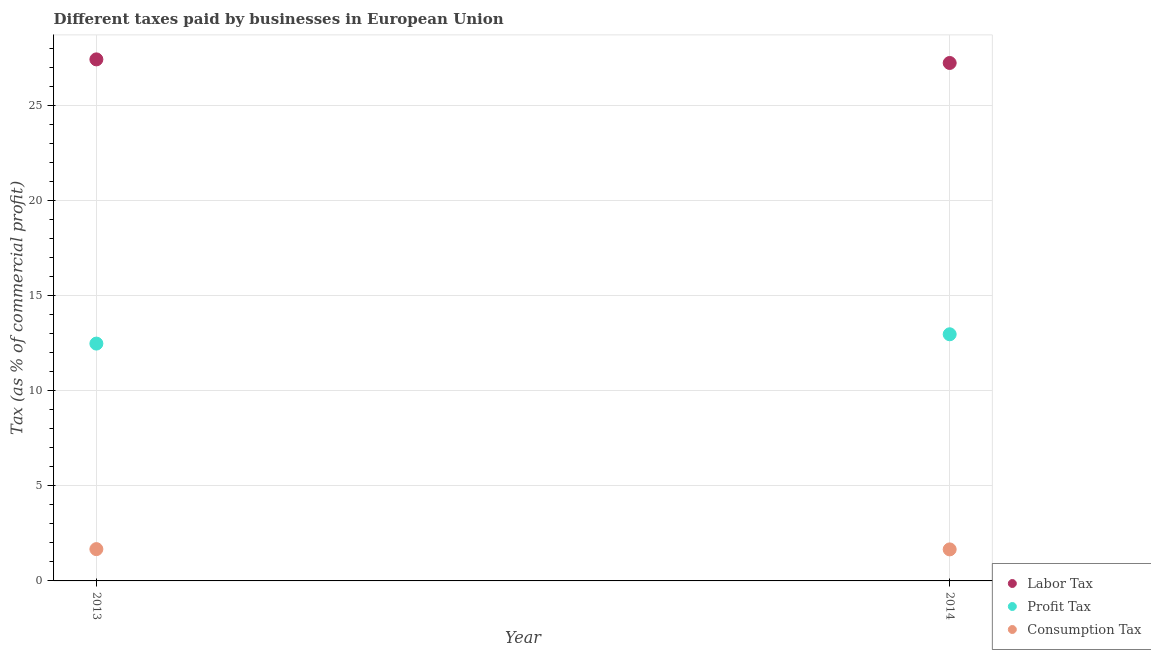How many different coloured dotlines are there?
Give a very brief answer. 3. Is the number of dotlines equal to the number of legend labels?
Provide a succinct answer. Yes. What is the percentage of labor tax in 2014?
Make the answer very short. 27.23. Across all years, what is the maximum percentage of profit tax?
Ensure brevity in your answer.  12.96. Across all years, what is the minimum percentage of profit tax?
Ensure brevity in your answer.  12.47. In which year was the percentage of consumption tax maximum?
Your response must be concise. 2013. What is the total percentage of consumption tax in the graph?
Provide a short and direct response. 3.33. What is the difference between the percentage of labor tax in 2013 and that in 2014?
Offer a terse response. 0.19. What is the difference between the percentage of profit tax in 2014 and the percentage of labor tax in 2013?
Provide a short and direct response. -14.45. What is the average percentage of consumption tax per year?
Your answer should be compact. 1.66. In the year 2014, what is the difference between the percentage of labor tax and percentage of consumption tax?
Offer a terse response. 25.57. In how many years, is the percentage of labor tax greater than 20 %?
Your answer should be compact. 2. What is the ratio of the percentage of profit tax in 2013 to that in 2014?
Keep it short and to the point. 0.96. Is the percentage of profit tax in 2013 less than that in 2014?
Ensure brevity in your answer.  Yes. How many years are there in the graph?
Your answer should be compact. 2. Does the graph contain any zero values?
Give a very brief answer. No. Does the graph contain grids?
Make the answer very short. Yes. Where does the legend appear in the graph?
Keep it short and to the point. Bottom right. How are the legend labels stacked?
Keep it short and to the point. Vertical. What is the title of the graph?
Keep it short and to the point. Different taxes paid by businesses in European Union. What is the label or title of the Y-axis?
Your answer should be compact. Tax (as % of commercial profit). What is the Tax (as % of commercial profit) in Labor Tax in 2013?
Ensure brevity in your answer.  27.41. What is the Tax (as % of commercial profit) in Profit Tax in 2013?
Provide a short and direct response. 12.47. What is the Tax (as % of commercial profit) of Consumption Tax in 2013?
Provide a succinct answer. 1.67. What is the Tax (as % of commercial profit) in Labor Tax in 2014?
Keep it short and to the point. 27.23. What is the Tax (as % of commercial profit) in Profit Tax in 2014?
Your response must be concise. 12.96. What is the Tax (as % of commercial profit) of Consumption Tax in 2014?
Offer a terse response. 1.66. Across all years, what is the maximum Tax (as % of commercial profit) of Labor Tax?
Your answer should be compact. 27.41. Across all years, what is the maximum Tax (as % of commercial profit) in Profit Tax?
Give a very brief answer. 12.96. Across all years, what is the maximum Tax (as % of commercial profit) in Consumption Tax?
Provide a succinct answer. 1.67. Across all years, what is the minimum Tax (as % of commercial profit) in Labor Tax?
Your response must be concise. 27.23. Across all years, what is the minimum Tax (as % of commercial profit) in Profit Tax?
Your answer should be very brief. 12.47. Across all years, what is the minimum Tax (as % of commercial profit) in Consumption Tax?
Make the answer very short. 1.66. What is the total Tax (as % of commercial profit) in Labor Tax in the graph?
Your answer should be very brief. 54.64. What is the total Tax (as % of commercial profit) in Profit Tax in the graph?
Ensure brevity in your answer.  25.44. What is the total Tax (as % of commercial profit) of Consumption Tax in the graph?
Offer a very short reply. 3.33. What is the difference between the Tax (as % of commercial profit) of Labor Tax in 2013 and that in 2014?
Provide a succinct answer. 0.19. What is the difference between the Tax (as % of commercial profit) of Profit Tax in 2013 and that in 2014?
Your answer should be compact. -0.49. What is the difference between the Tax (as % of commercial profit) of Consumption Tax in 2013 and that in 2014?
Your answer should be compact. 0.01. What is the difference between the Tax (as % of commercial profit) of Labor Tax in 2013 and the Tax (as % of commercial profit) of Profit Tax in 2014?
Give a very brief answer. 14.45. What is the difference between the Tax (as % of commercial profit) of Labor Tax in 2013 and the Tax (as % of commercial profit) of Consumption Tax in 2014?
Provide a short and direct response. 25.76. What is the difference between the Tax (as % of commercial profit) in Profit Tax in 2013 and the Tax (as % of commercial profit) in Consumption Tax in 2014?
Provide a succinct answer. 10.82. What is the average Tax (as % of commercial profit) of Labor Tax per year?
Make the answer very short. 27.32. What is the average Tax (as % of commercial profit) of Profit Tax per year?
Ensure brevity in your answer.  12.72. What is the average Tax (as % of commercial profit) of Consumption Tax per year?
Provide a short and direct response. 1.66. In the year 2013, what is the difference between the Tax (as % of commercial profit) in Labor Tax and Tax (as % of commercial profit) in Profit Tax?
Your answer should be very brief. 14.94. In the year 2013, what is the difference between the Tax (as % of commercial profit) in Labor Tax and Tax (as % of commercial profit) in Consumption Tax?
Keep it short and to the point. 25.74. In the year 2013, what is the difference between the Tax (as % of commercial profit) of Profit Tax and Tax (as % of commercial profit) of Consumption Tax?
Keep it short and to the point. 10.8. In the year 2014, what is the difference between the Tax (as % of commercial profit) in Labor Tax and Tax (as % of commercial profit) in Profit Tax?
Provide a short and direct response. 14.26. In the year 2014, what is the difference between the Tax (as % of commercial profit) of Labor Tax and Tax (as % of commercial profit) of Consumption Tax?
Provide a succinct answer. 25.57. In the year 2014, what is the difference between the Tax (as % of commercial profit) of Profit Tax and Tax (as % of commercial profit) of Consumption Tax?
Provide a succinct answer. 11.31. What is the ratio of the Tax (as % of commercial profit) in Profit Tax in 2013 to that in 2014?
Offer a terse response. 0.96. What is the ratio of the Tax (as % of commercial profit) in Consumption Tax in 2013 to that in 2014?
Make the answer very short. 1.01. What is the difference between the highest and the second highest Tax (as % of commercial profit) in Labor Tax?
Your response must be concise. 0.19. What is the difference between the highest and the second highest Tax (as % of commercial profit) of Profit Tax?
Keep it short and to the point. 0.49. What is the difference between the highest and the second highest Tax (as % of commercial profit) of Consumption Tax?
Provide a short and direct response. 0.01. What is the difference between the highest and the lowest Tax (as % of commercial profit) of Labor Tax?
Provide a succinct answer. 0.19. What is the difference between the highest and the lowest Tax (as % of commercial profit) in Profit Tax?
Your answer should be very brief. 0.49. What is the difference between the highest and the lowest Tax (as % of commercial profit) in Consumption Tax?
Provide a succinct answer. 0.01. 